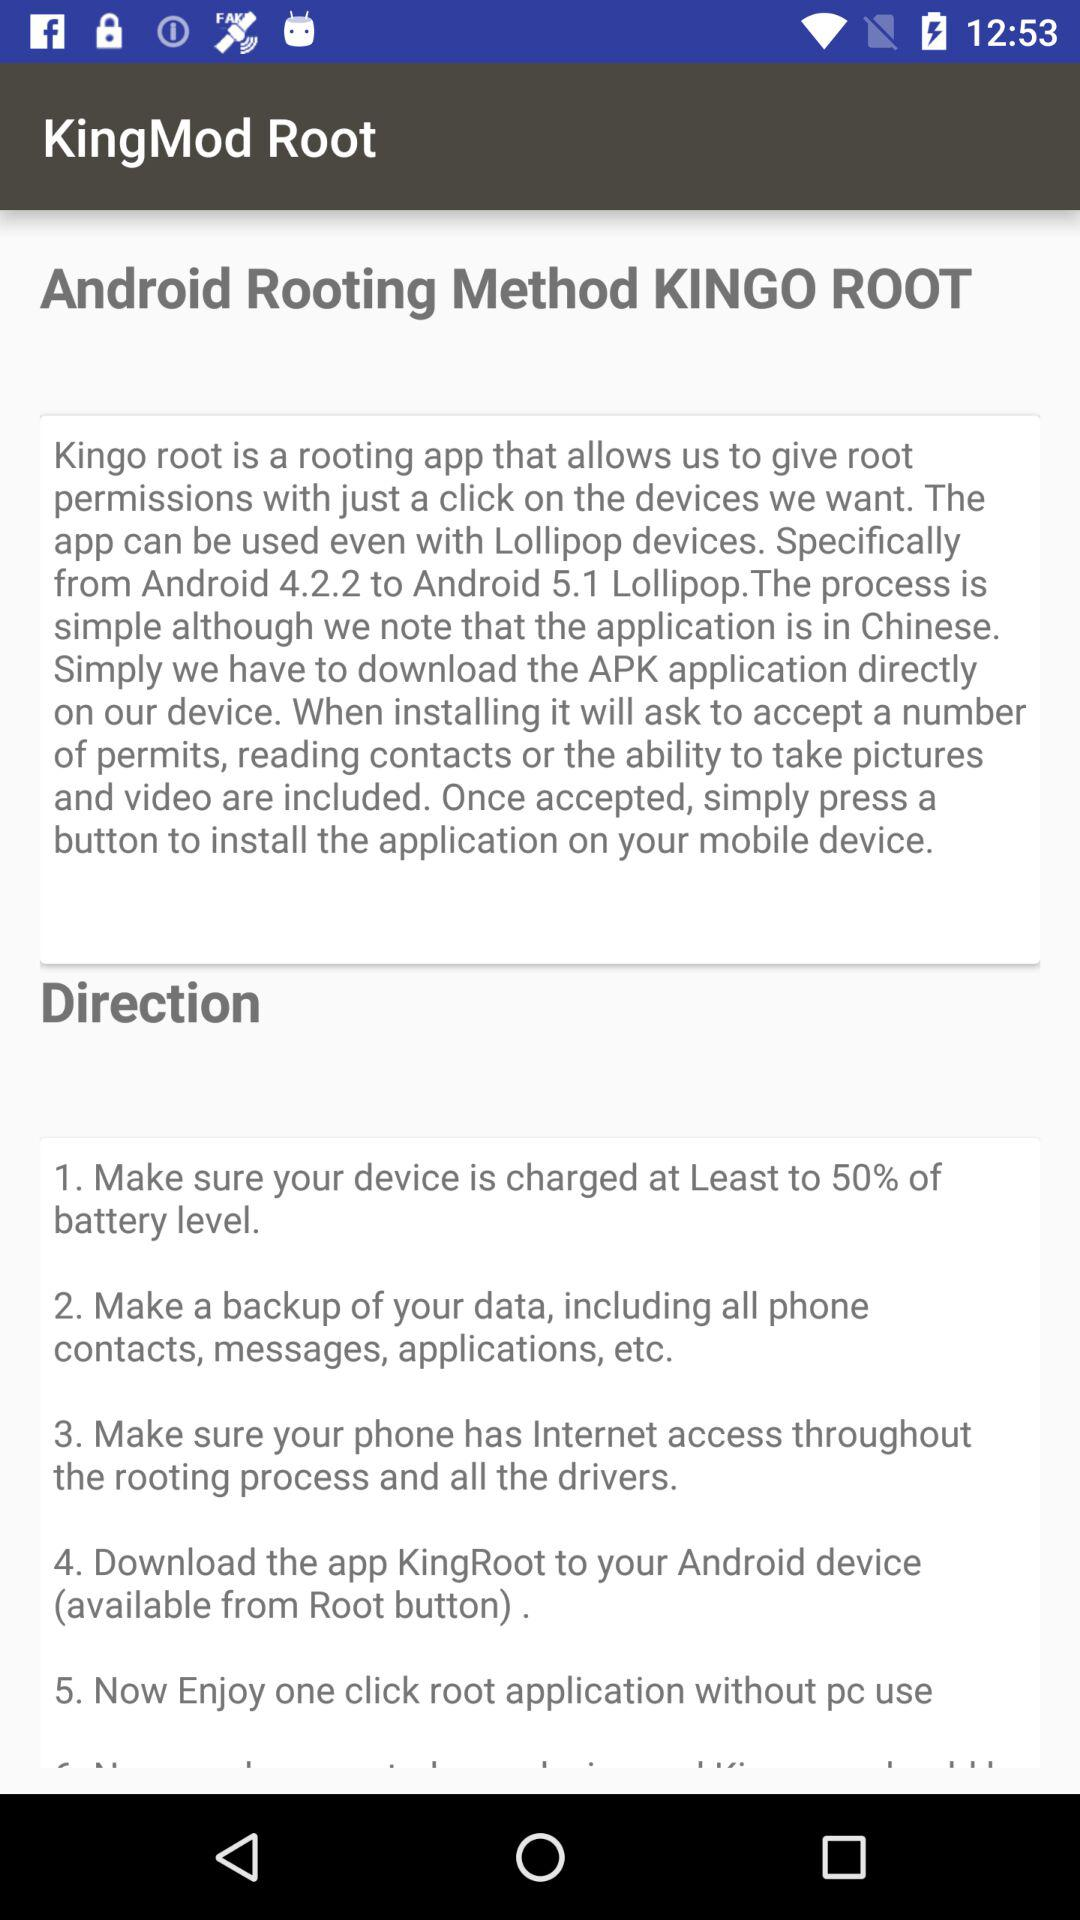How many steps are there in the rooting process?
Answer the question using a single word or phrase. 5 